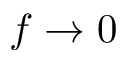<formula> <loc_0><loc_0><loc_500><loc_500>f \rightarrow 0</formula> 